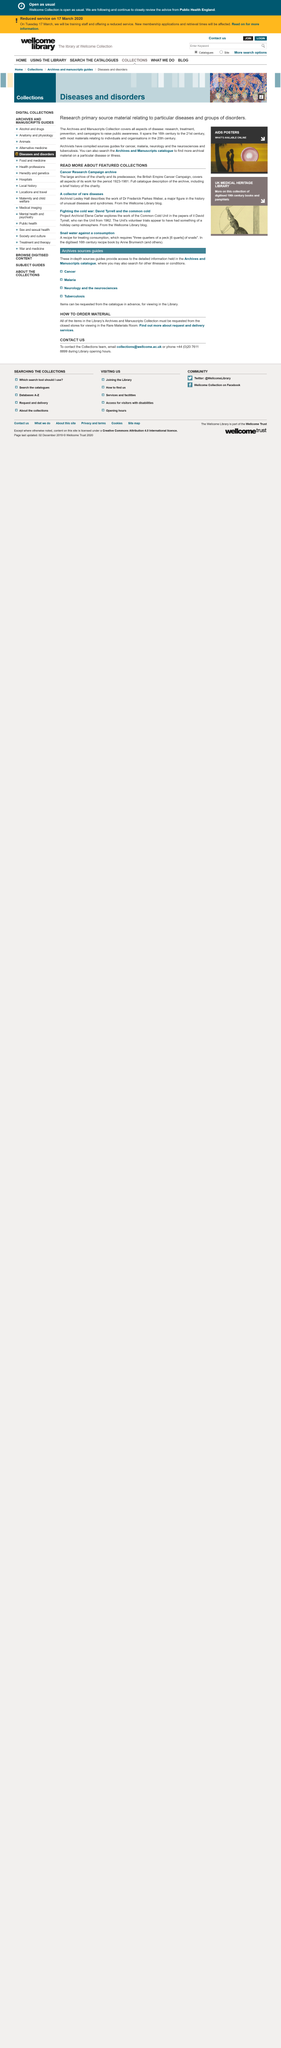List a handful of essential elements in this visual. Dr. Frederick Parkes Weber is a prominent figure in the field of unusual diseases and syndromes, and is widely recognized as a major figure in the history of such conditions. The Cancer Research Campaign archive covers the period of work from 1923 to 1981. The Cancer Research Campaign's predecessor was known as the British Empire Cancer Campaign. 